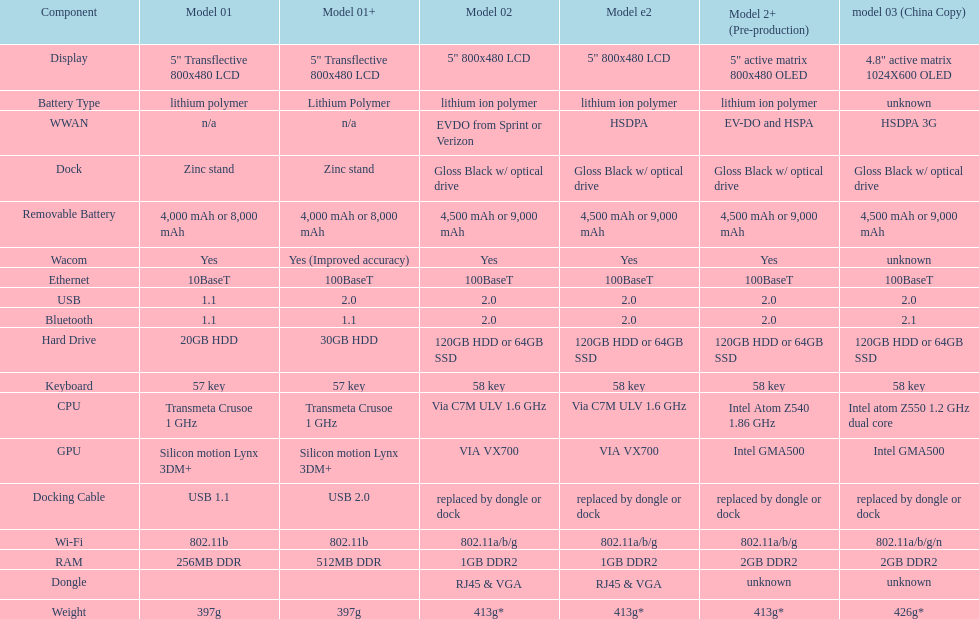What is the average number of models that have usb 2.0? 5. 